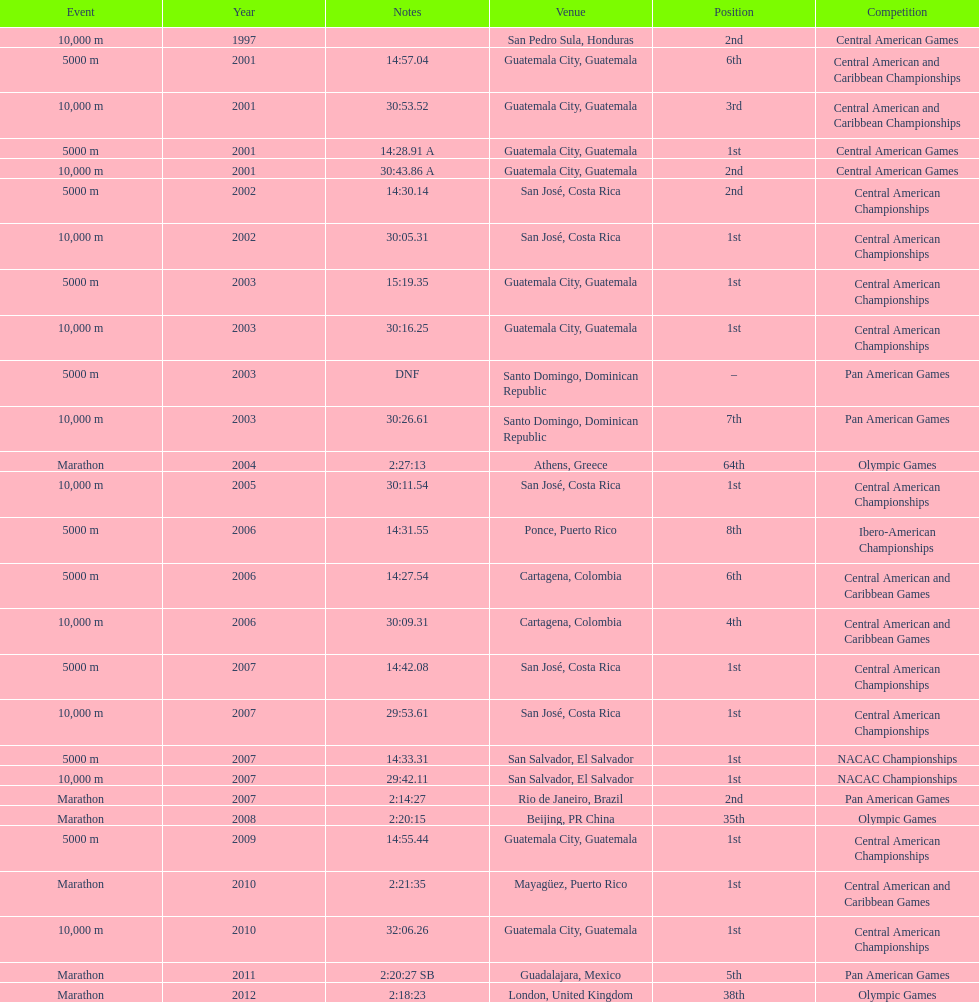How many times has the position of 1st been achieved? 12. 